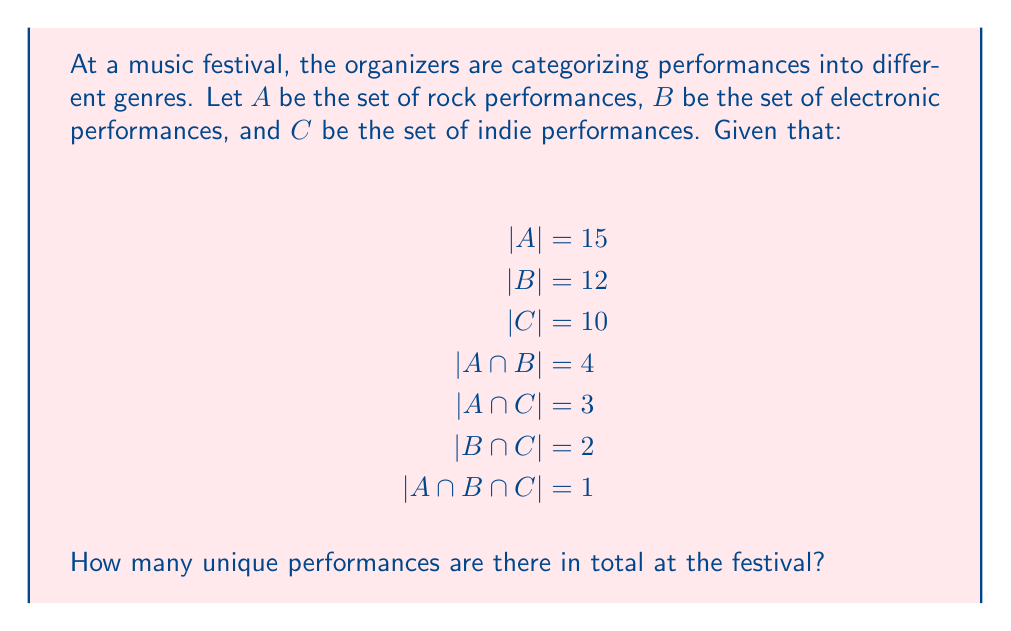Show me your answer to this math problem. To solve this problem, we'll use the principle of inclusion-exclusion for three sets. The formula for the number of elements in the union of three sets A, B, and C is:

$|A \cup B \cup C| = |A| + |B| + |C| - |A \cap B| - |A \cap C| - |B \cap C| + |A \cap B \cap C|$

Let's substitute the given values:

1. $|A| = 15$
2. $|B| = 12$
3. $|C| = 10$
4. $|A \cap B| = 4$
5. $|A \cap C| = 3$
6. $|B \cap C| = 2$
7. $|A \cap B \cap C| = 1$

Now, let's calculate:

$|A \cup B \cup C| = 15 + 12 + 10 - 4 - 3 - 2 + 1$

$|A \cup B \cup C| = 37 - 9 + 1$

$|A \cup B \cup C| = 29$

Therefore, there are 29 unique performances at the festival.

This method accounts for performances that might fall into multiple genres (like rock-electronic fusion or indie-rock) without counting them multiple times.
Answer: 29 unique performances 